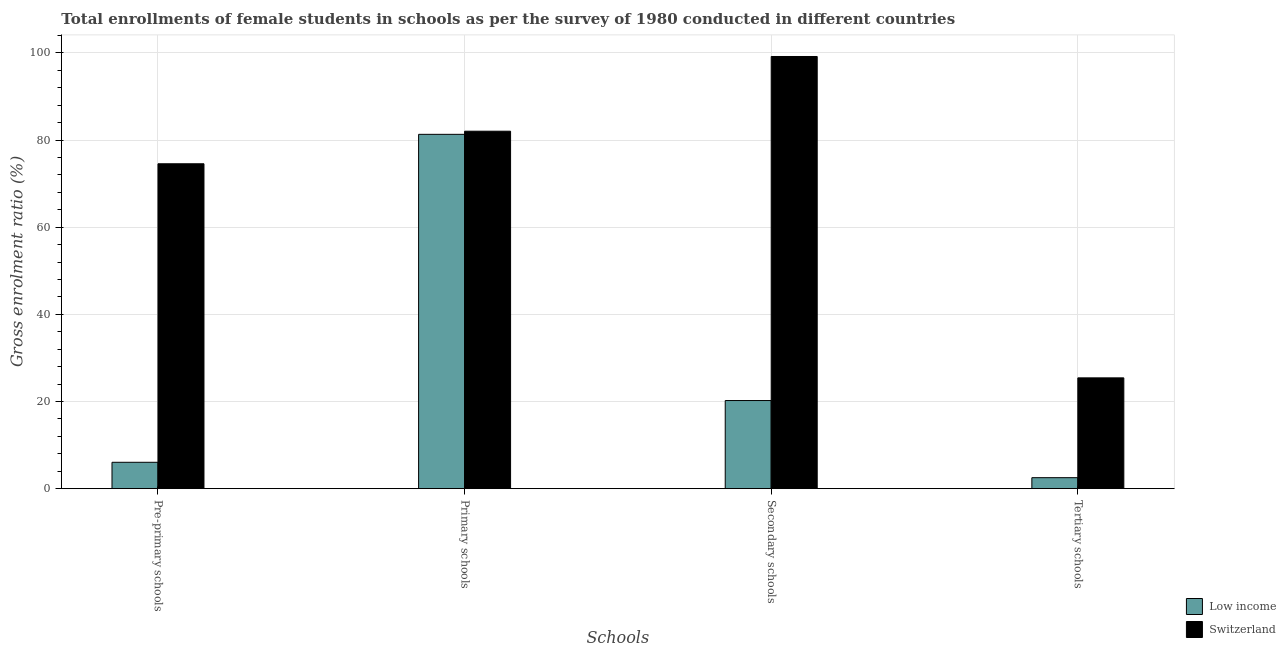How many groups of bars are there?
Give a very brief answer. 4. What is the label of the 3rd group of bars from the left?
Provide a succinct answer. Secondary schools. What is the gross enrolment ratio(female) in primary schools in Switzerland?
Give a very brief answer. 82.02. Across all countries, what is the maximum gross enrolment ratio(female) in pre-primary schools?
Your answer should be compact. 74.55. Across all countries, what is the minimum gross enrolment ratio(female) in secondary schools?
Your response must be concise. 20.22. In which country was the gross enrolment ratio(female) in primary schools maximum?
Your response must be concise. Switzerland. In which country was the gross enrolment ratio(female) in primary schools minimum?
Your answer should be compact. Low income. What is the total gross enrolment ratio(female) in secondary schools in the graph?
Give a very brief answer. 119.39. What is the difference between the gross enrolment ratio(female) in tertiary schools in Low income and that in Switzerland?
Give a very brief answer. -22.91. What is the difference between the gross enrolment ratio(female) in secondary schools in Low income and the gross enrolment ratio(female) in pre-primary schools in Switzerland?
Give a very brief answer. -54.32. What is the average gross enrolment ratio(female) in tertiary schools per country?
Offer a terse response. 13.97. What is the difference between the gross enrolment ratio(female) in secondary schools and gross enrolment ratio(female) in primary schools in Switzerland?
Your answer should be very brief. 17.15. In how many countries, is the gross enrolment ratio(female) in tertiary schools greater than 8 %?
Your response must be concise. 1. What is the ratio of the gross enrolment ratio(female) in pre-primary schools in Low income to that in Switzerland?
Keep it short and to the point. 0.08. Is the gross enrolment ratio(female) in tertiary schools in Low income less than that in Switzerland?
Your response must be concise. Yes. What is the difference between the highest and the second highest gross enrolment ratio(female) in primary schools?
Ensure brevity in your answer.  0.72. What is the difference between the highest and the lowest gross enrolment ratio(female) in tertiary schools?
Offer a very short reply. 22.91. In how many countries, is the gross enrolment ratio(female) in tertiary schools greater than the average gross enrolment ratio(female) in tertiary schools taken over all countries?
Ensure brevity in your answer.  1. Is the sum of the gross enrolment ratio(female) in primary schools in Switzerland and Low income greater than the maximum gross enrolment ratio(female) in pre-primary schools across all countries?
Provide a succinct answer. Yes. Is it the case that in every country, the sum of the gross enrolment ratio(female) in tertiary schools and gross enrolment ratio(female) in primary schools is greater than the sum of gross enrolment ratio(female) in secondary schools and gross enrolment ratio(female) in pre-primary schools?
Keep it short and to the point. Yes. What does the 2nd bar from the left in Pre-primary schools represents?
Offer a very short reply. Switzerland. What does the 1st bar from the right in Tertiary schools represents?
Keep it short and to the point. Switzerland. How many bars are there?
Ensure brevity in your answer.  8. How many countries are there in the graph?
Provide a short and direct response. 2. Are the values on the major ticks of Y-axis written in scientific E-notation?
Your response must be concise. No. Does the graph contain grids?
Ensure brevity in your answer.  Yes. Where does the legend appear in the graph?
Your answer should be compact. Bottom right. How many legend labels are there?
Offer a terse response. 2. How are the legend labels stacked?
Make the answer very short. Vertical. What is the title of the graph?
Give a very brief answer. Total enrollments of female students in schools as per the survey of 1980 conducted in different countries. Does "St. Lucia" appear as one of the legend labels in the graph?
Your answer should be compact. No. What is the label or title of the X-axis?
Ensure brevity in your answer.  Schools. What is the label or title of the Y-axis?
Your answer should be compact. Gross enrolment ratio (%). What is the Gross enrolment ratio (%) of Low income in Pre-primary schools?
Provide a short and direct response. 6.05. What is the Gross enrolment ratio (%) of Switzerland in Pre-primary schools?
Offer a very short reply. 74.55. What is the Gross enrolment ratio (%) of Low income in Primary schools?
Offer a terse response. 81.3. What is the Gross enrolment ratio (%) of Switzerland in Primary schools?
Provide a short and direct response. 82.02. What is the Gross enrolment ratio (%) in Low income in Secondary schools?
Make the answer very short. 20.22. What is the Gross enrolment ratio (%) of Switzerland in Secondary schools?
Your answer should be compact. 99.17. What is the Gross enrolment ratio (%) in Low income in Tertiary schools?
Make the answer very short. 2.52. What is the Gross enrolment ratio (%) in Switzerland in Tertiary schools?
Your answer should be compact. 25.43. Across all Schools, what is the maximum Gross enrolment ratio (%) in Low income?
Your answer should be very brief. 81.3. Across all Schools, what is the maximum Gross enrolment ratio (%) of Switzerland?
Provide a succinct answer. 99.17. Across all Schools, what is the minimum Gross enrolment ratio (%) in Low income?
Keep it short and to the point. 2.52. Across all Schools, what is the minimum Gross enrolment ratio (%) of Switzerland?
Keep it short and to the point. 25.43. What is the total Gross enrolment ratio (%) of Low income in the graph?
Give a very brief answer. 110.1. What is the total Gross enrolment ratio (%) of Switzerland in the graph?
Give a very brief answer. 281.16. What is the difference between the Gross enrolment ratio (%) of Low income in Pre-primary schools and that in Primary schools?
Offer a very short reply. -75.25. What is the difference between the Gross enrolment ratio (%) in Switzerland in Pre-primary schools and that in Primary schools?
Provide a short and direct response. -7.47. What is the difference between the Gross enrolment ratio (%) in Low income in Pre-primary schools and that in Secondary schools?
Offer a very short reply. -14.17. What is the difference between the Gross enrolment ratio (%) in Switzerland in Pre-primary schools and that in Secondary schools?
Keep it short and to the point. -24.62. What is the difference between the Gross enrolment ratio (%) of Low income in Pre-primary schools and that in Tertiary schools?
Your response must be concise. 3.53. What is the difference between the Gross enrolment ratio (%) in Switzerland in Pre-primary schools and that in Tertiary schools?
Give a very brief answer. 49.12. What is the difference between the Gross enrolment ratio (%) in Low income in Primary schools and that in Secondary schools?
Your response must be concise. 61.08. What is the difference between the Gross enrolment ratio (%) of Switzerland in Primary schools and that in Secondary schools?
Give a very brief answer. -17.15. What is the difference between the Gross enrolment ratio (%) of Low income in Primary schools and that in Tertiary schools?
Offer a terse response. 78.78. What is the difference between the Gross enrolment ratio (%) in Switzerland in Primary schools and that in Tertiary schools?
Provide a short and direct response. 56.59. What is the difference between the Gross enrolment ratio (%) of Low income in Secondary schools and that in Tertiary schools?
Your answer should be very brief. 17.7. What is the difference between the Gross enrolment ratio (%) in Switzerland in Secondary schools and that in Tertiary schools?
Provide a succinct answer. 73.74. What is the difference between the Gross enrolment ratio (%) of Low income in Pre-primary schools and the Gross enrolment ratio (%) of Switzerland in Primary schools?
Provide a succinct answer. -75.97. What is the difference between the Gross enrolment ratio (%) in Low income in Pre-primary schools and the Gross enrolment ratio (%) in Switzerland in Secondary schools?
Make the answer very short. -93.11. What is the difference between the Gross enrolment ratio (%) in Low income in Pre-primary schools and the Gross enrolment ratio (%) in Switzerland in Tertiary schools?
Offer a very short reply. -19.37. What is the difference between the Gross enrolment ratio (%) of Low income in Primary schools and the Gross enrolment ratio (%) of Switzerland in Secondary schools?
Your response must be concise. -17.86. What is the difference between the Gross enrolment ratio (%) of Low income in Primary schools and the Gross enrolment ratio (%) of Switzerland in Tertiary schools?
Your answer should be compact. 55.88. What is the difference between the Gross enrolment ratio (%) in Low income in Secondary schools and the Gross enrolment ratio (%) in Switzerland in Tertiary schools?
Offer a very short reply. -5.2. What is the average Gross enrolment ratio (%) in Low income per Schools?
Offer a very short reply. 27.53. What is the average Gross enrolment ratio (%) in Switzerland per Schools?
Offer a very short reply. 70.29. What is the difference between the Gross enrolment ratio (%) of Low income and Gross enrolment ratio (%) of Switzerland in Pre-primary schools?
Offer a terse response. -68.49. What is the difference between the Gross enrolment ratio (%) of Low income and Gross enrolment ratio (%) of Switzerland in Primary schools?
Provide a succinct answer. -0.72. What is the difference between the Gross enrolment ratio (%) of Low income and Gross enrolment ratio (%) of Switzerland in Secondary schools?
Keep it short and to the point. -78.94. What is the difference between the Gross enrolment ratio (%) in Low income and Gross enrolment ratio (%) in Switzerland in Tertiary schools?
Keep it short and to the point. -22.91. What is the ratio of the Gross enrolment ratio (%) of Low income in Pre-primary schools to that in Primary schools?
Offer a very short reply. 0.07. What is the ratio of the Gross enrolment ratio (%) in Switzerland in Pre-primary schools to that in Primary schools?
Provide a short and direct response. 0.91. What is the ratio of the Gross enrolment ratio (%) of Low income in Pre-primary schools to that in Secondary schools?
Offer a very short reply. 0.3. What is the ratio of the Gross enrolment ratio (%) in Switzerland in Pre-primary schools to that in Secondary schools?
Offer a very short reply. 0.75. What is the ratio of the Gross enrolment ratio (%) in Low income in Pre-primary schools to that in Tertiary schools?
Your answer should be very brief. 2.4. What is the ratio of the Gross enrolment ratio (%) of Switzerland in Pre-primary schools to that in Tertiary schools?
Offer a very short reply. 2.93. What is the ratio of the Gross enrolment ratio (%) of Low income in Primary schools to that in Secondary schools?
Keep it short and to the point. 4.02. What is the ratio of the Gross enrolment ratio (%) in Switzerland in Primary schools to that in Secondary schools?
Make the answer very short. 0.83. What is the ratio of the Gross enrolment ratio (%) in Low income in Primary schools to that in Tertiary schools?
Provide a succinct answer. 32.24. What is the ratio of the Gross enrolment ratio (%) in Switzerland in Primary schools to that in Tertiary schools?
Ensure brevity in your answer.  3.23. What is the ratio of the Gross enrolment ratio (%) of Low income in Secondary schools to that in Tertiary schools?
Make the answer very short. 8.02. What is the ratio of the Gross enrolment ratio (%) of Switzerland in Secondary schools to that in Tertiary schools?
Give a very brief answer. 3.9. What is the difference between the highest and the second highest Gross enrolment ratio (%) of Low income?
Provide a succinct answer. 61.08. What is the difference between the highest and the second highest Gross enrolment ratio (%) in Switzerland?
Offer a very short reply. 17.15. What is the difference between the highest and the lowest Gross enrolment ratio (%) of Low income?
Keep it short and to the point. 78.78. What is the difference between the highest and the lowest Gross enrolment ratio (%) in Switzerland?
Provide a succinct answer. 73.74. 